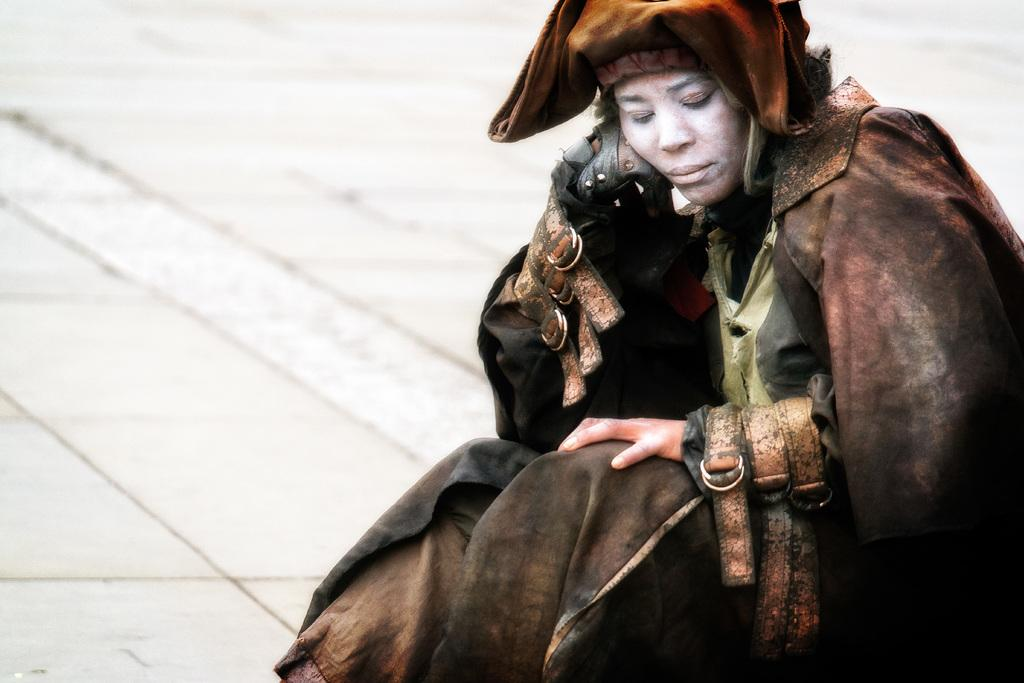Where was the image taken? The image was taken outdoors. What can be seen at the bottom of the image? There is a floor visible at the bottom of the image. What is the woman in the image doing? The woman is sitting on the floor on the right side of the image. What type of pan can be seen in the woman's hand in the image? There is no pan visible in the woman's hand in the image. 